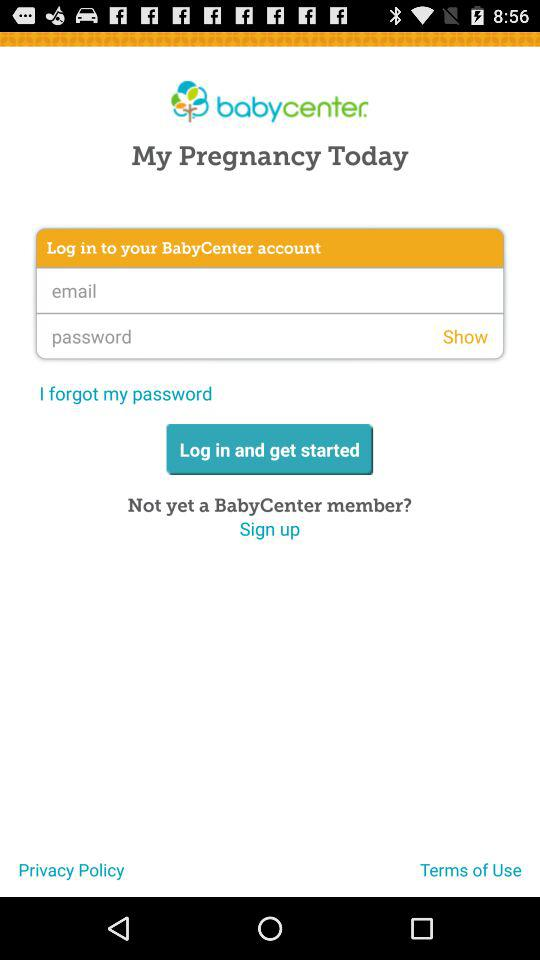What is the name of the application? The name of the application is "babycenter". 